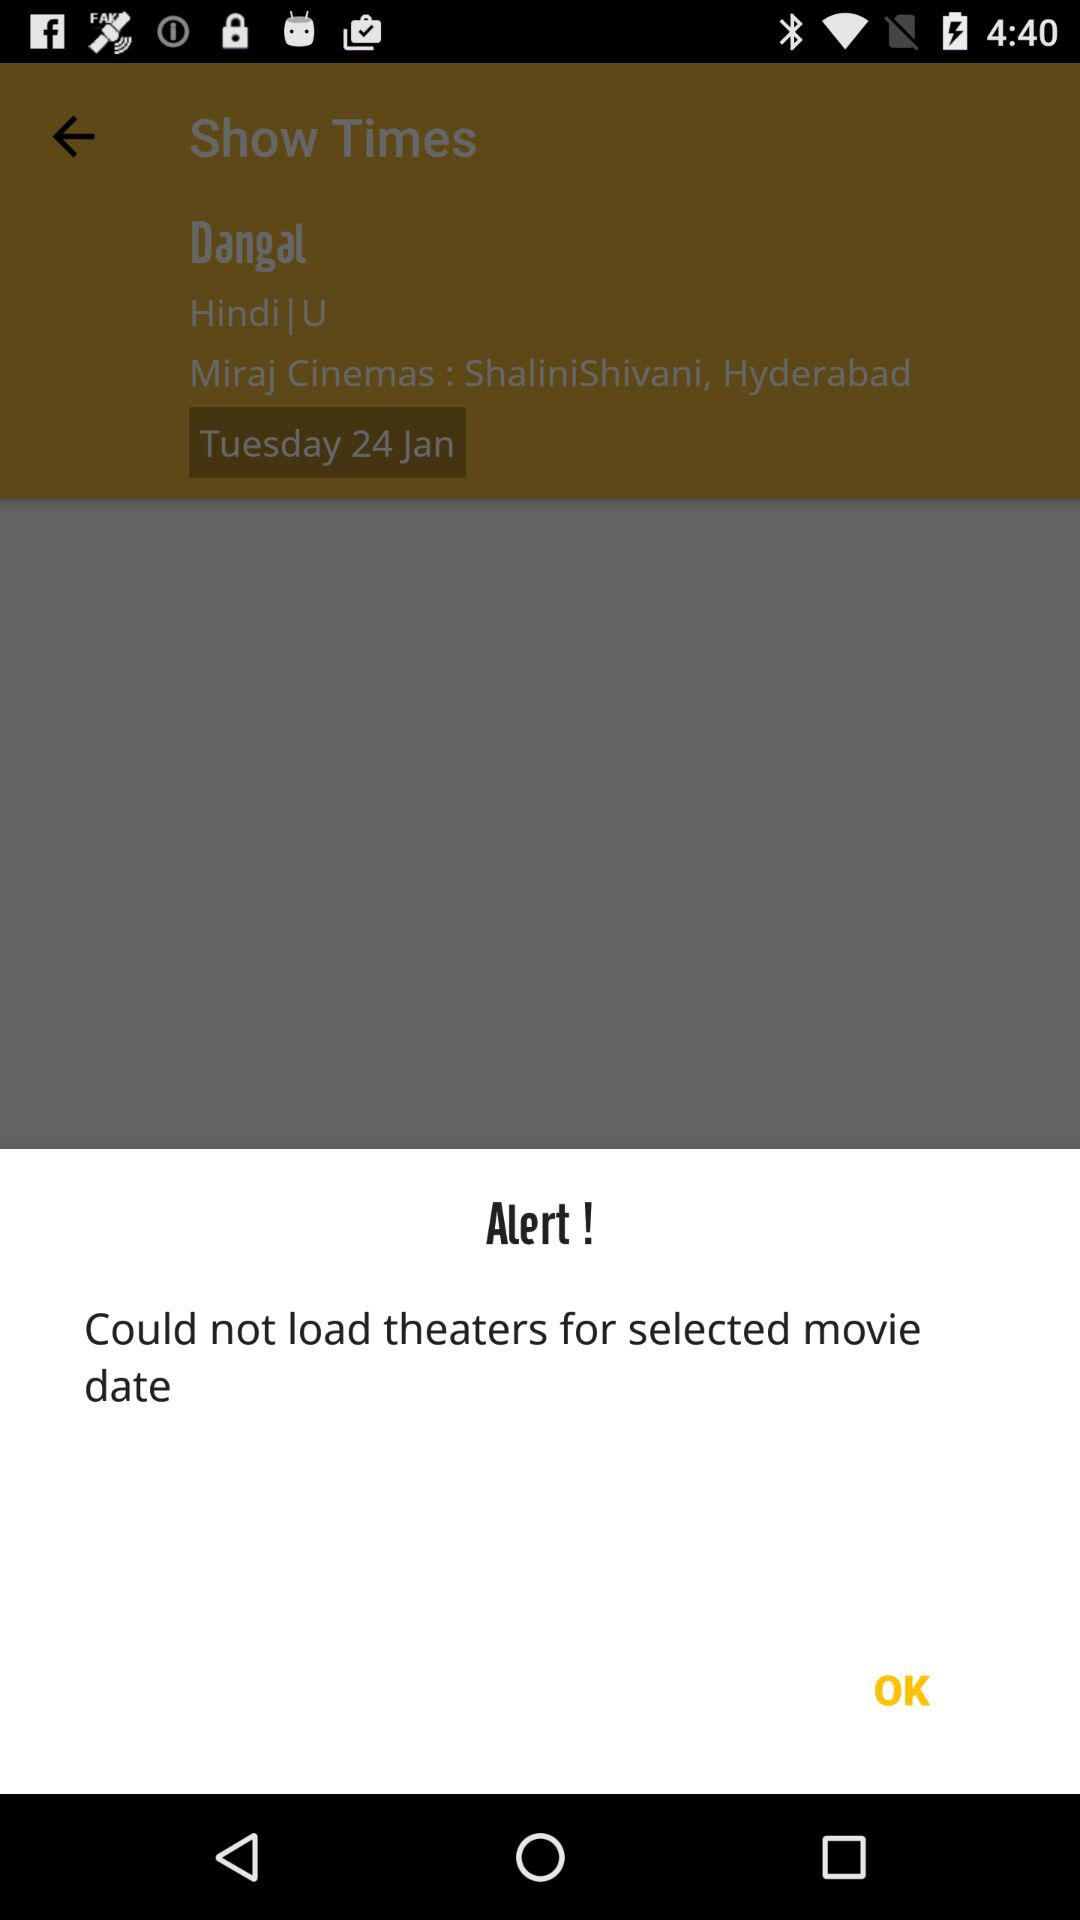What is the name of the mentioned movie? The name of the mentioned movie is "Dangal". 